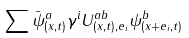Convert formula to latex. <formula><loc_0><loc_0><loc_500><loc_500>\sum \bar { \psi } _ { ( { x } , t ) } ^ { a } \gamma ^ { i } U _ { ( { x } , t ) , { e } _ { i } } ^ { a b } \psi ^ { b } _ { ( { x + e } _ { i } , t ) }</formula> 